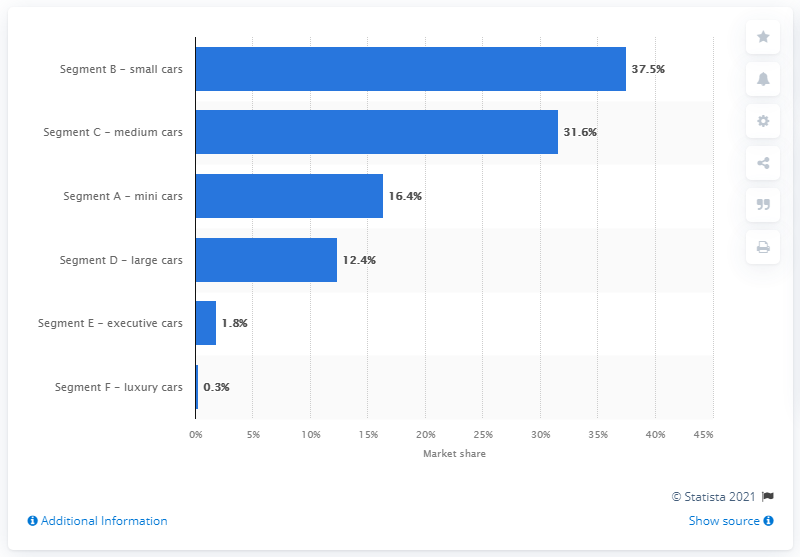Highlight a few significant elements in this photo. In 2020, small cars in the B-segment accounted for approximately 37.5% of Italy's car market. The F-segment holds a significant 0.3% of the Italian car market. 